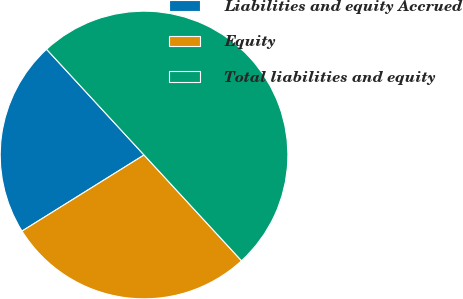<chart> <loc_0><loc_0><loc_500><loc_500><pie_chart><fcel>Liabilities and equity Accrued<fcel>Equity<fcel>Total liabilities and equity<nl><fcel>22.02%<fcel>27.98%<fcel>50.0%<nl></chart> 